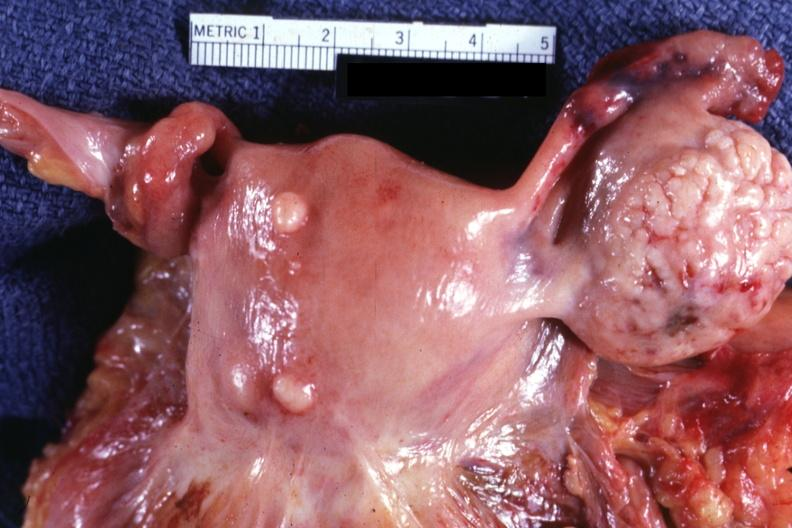what represent?
Answer the question using a single word or phrase. External view of uterus with two small subserosal myomas and a bulge 